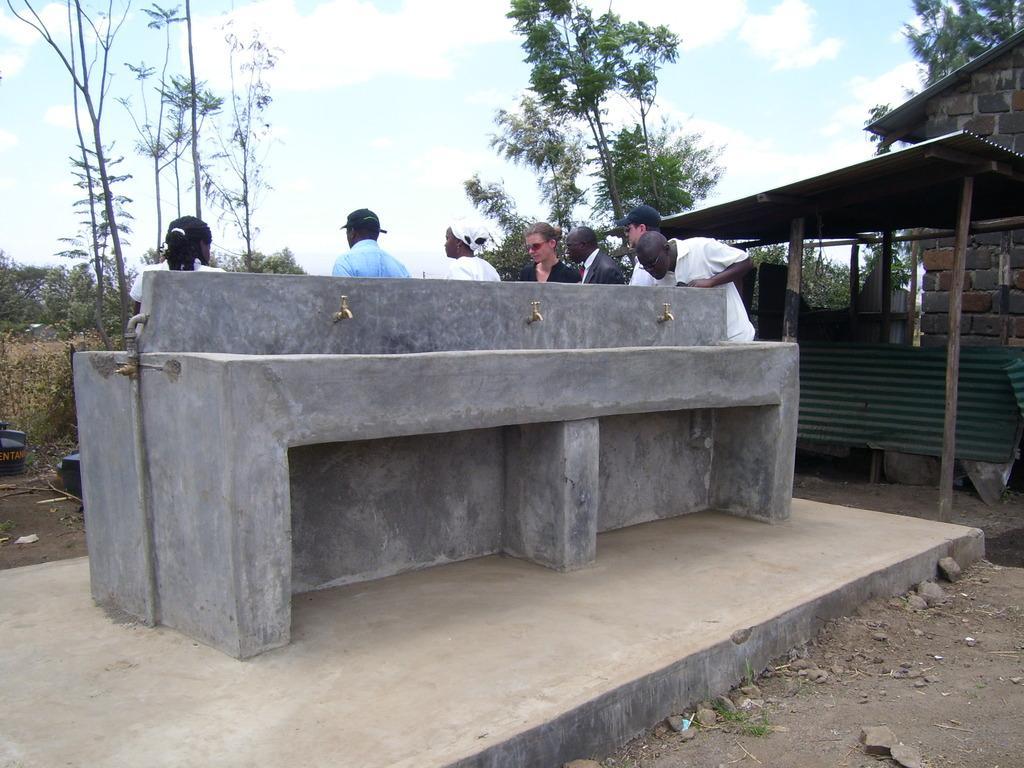Describe this image in one or two sentences. In this image we can see persons, pipeline, taps, shed, walls built with cobblestones, trees, plants and sky with clouds. 